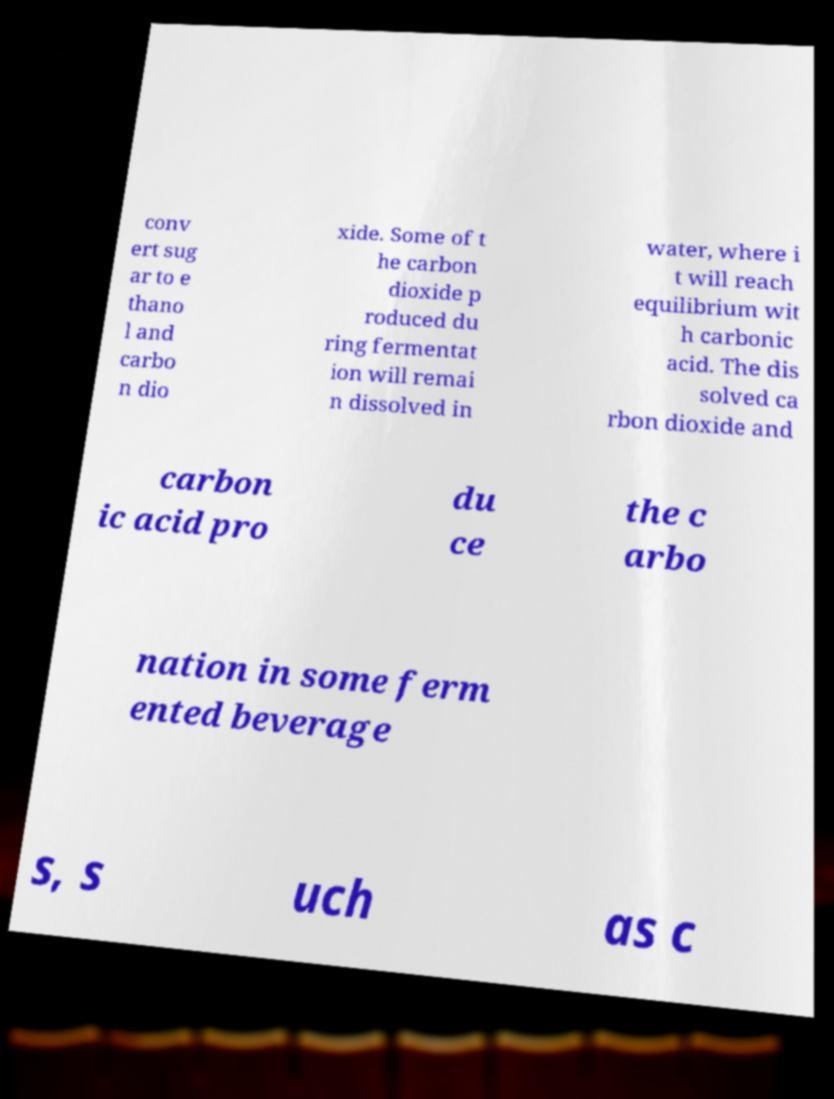For documentation purposes, I need the text within this image transcribed. Could you provide that? conv ert sug ar to e thano l and carbo n dio xide. Some of t he carbon dioxide p roduced du ring fermentat ion will remai n dissolved in water, where i t will reach equilibrium wit h carbonic acid. The dis solved ca rbon dioxide and carbon ic acid pro du ce the c arbo nation in some ferm ented beverage s, s uch as c 